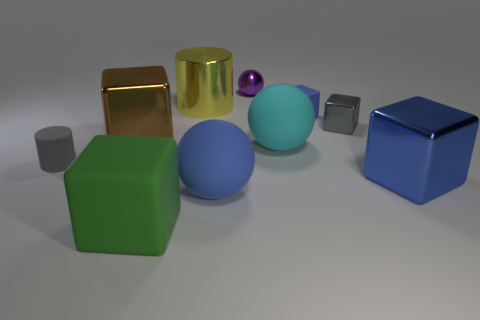How many other objects are the same color as the small cylinder?
Offer a terse response. 1. How big is the yellow shiny thing that is behind the blue block that is to the right of the small gray metallic cube?
Provide a succinct answer. Large. Does the sphere that is behind the brown cube have the same material as the big brown thing?
Ensure brevity in your answer.  Yes. What shape is the gray object that is right of the small gray matte cylinder?
Your answer should be compact. Cube. What number of blue balls are the same size as the yellow metallic cylinder?
Your answer should be very brief. 1. The cyan rubber object is what size?
Provide a succinct answer. Large. How many cyan objects are in front of the big green block?
Make the answer very short. 0. There is a large blue thing that is made of the same material as the big cyan object; what shape is it?
Give a very brief answer. Sphere. Is the number of metal blocks on the right side of the yellow cylinder less than the number of tiny things on the right side of the gray rubber thing?
Make the answer very short. Yes. Is the number of brown metal things greater than the number of red metallic balls?
Keep it short and to the point. Yes. 